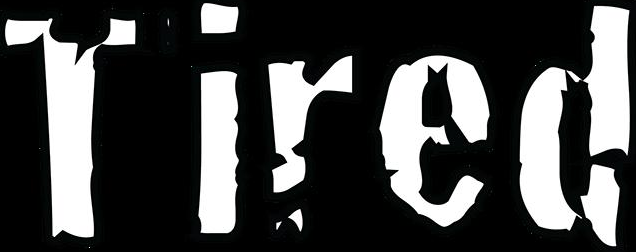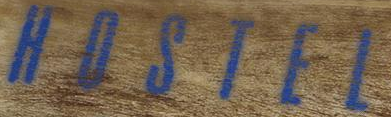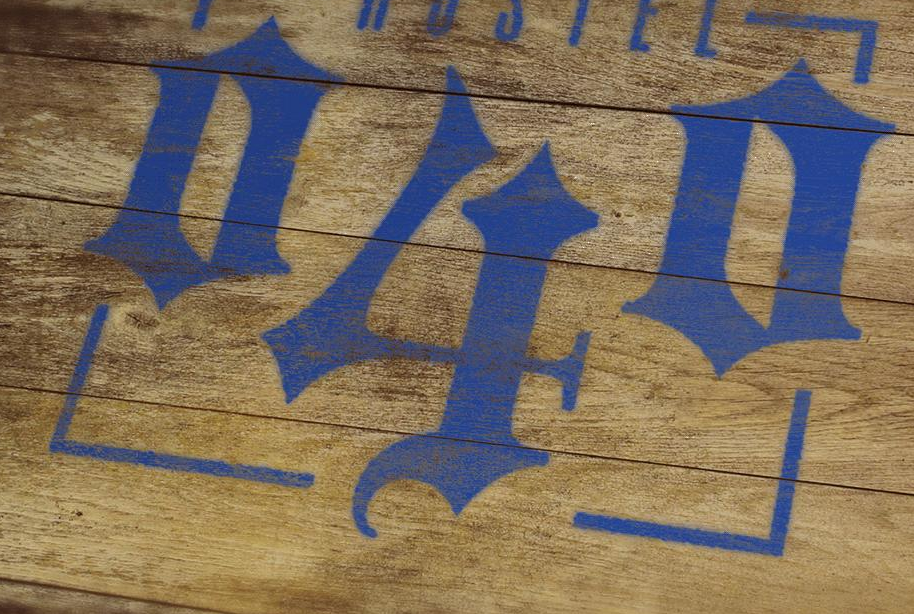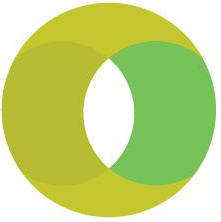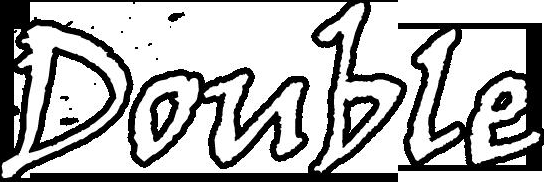What text is displayed in these images sequentially, separated by a semicolon? Tired; HOSTEL; 040; O; Double 